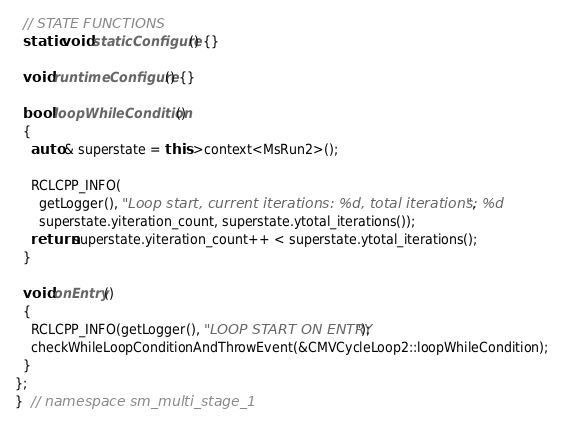<code> <loc_0><loc_0><loc_500><loc_500><_C++_>
  // STATE FUNCTIONS
  static void staticConfigure() {}

  void runtimeConfigure() {}

  bool loopWhileCondition()
  {
    auto & superstate = this->context<MsRun2>();

    RCLCPP_INFO(
      getLogger(), "Loop start, current iterations: %d, total iterations: %d",
      superstate.yiteration_count, superstate.ytotal_iterations());
    return superstate.yiteration_count++ < superstate.ytotal_iterations();
  }

  void onEntry()
  {
    RCLCPP_INFO(getLogger(), "LOOP START ON ENTRY");
    checkWhileLoopConditionAndThrowEvent(&CMVCycleLoop2::loopWhileCondition);
  }
};
}  // namespace sm_multi_stage_1
</code> 